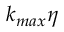<formula> <loc_0><loc_0><loc_500><loc_500>k _ { \max } \eta</formula> 